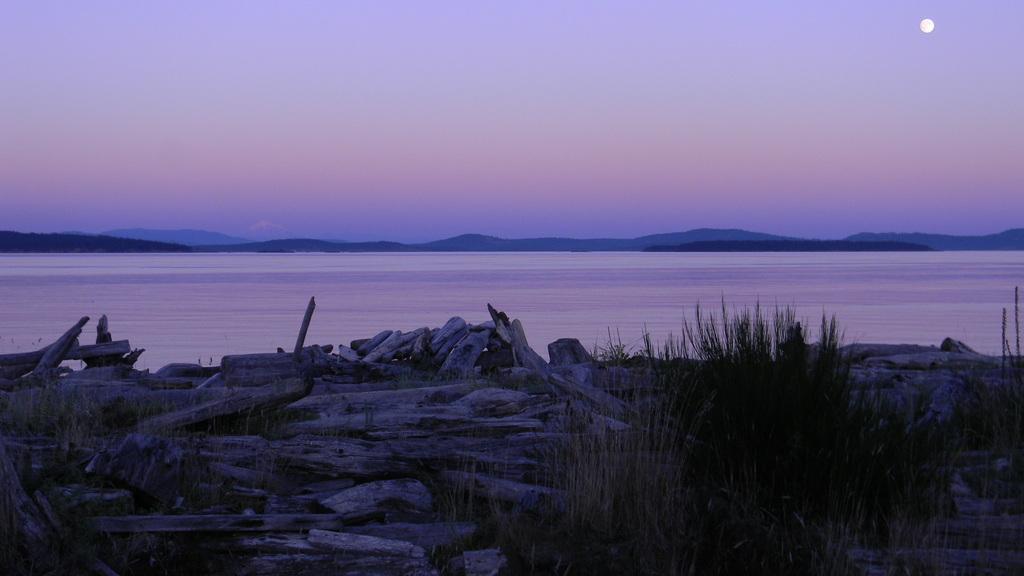Describe this image in one or two sentences. In this image we can see the a sea, there are some plants, wooden sticks and mountains, in the background we can see the moon and the sky. 